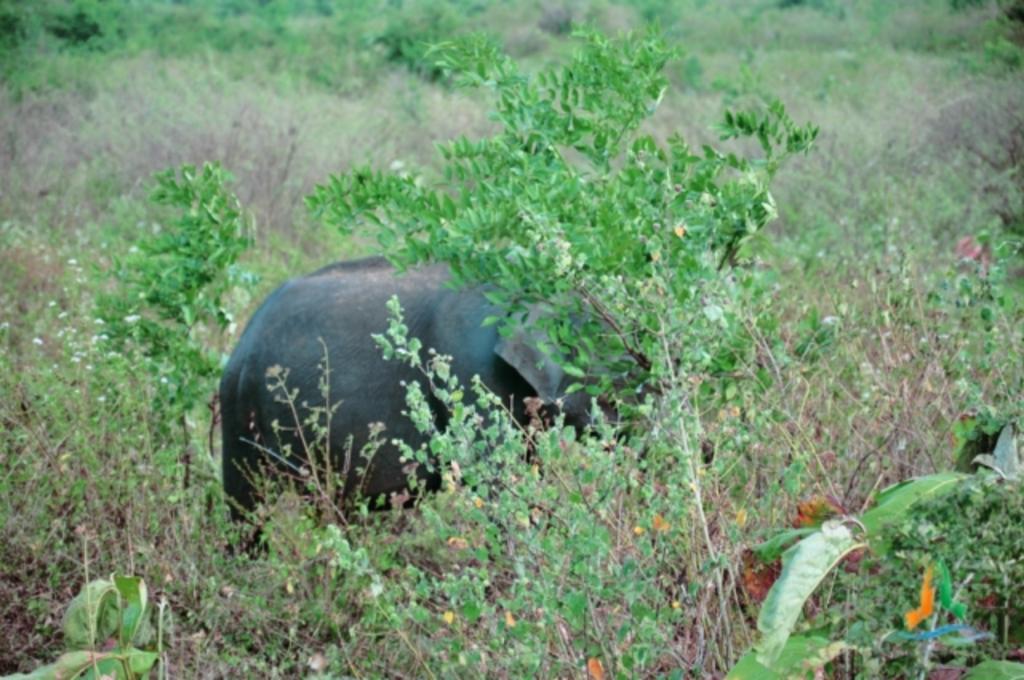Please provide a concise description of this image. In the image there are plants and in between the plants there is an elephant. 